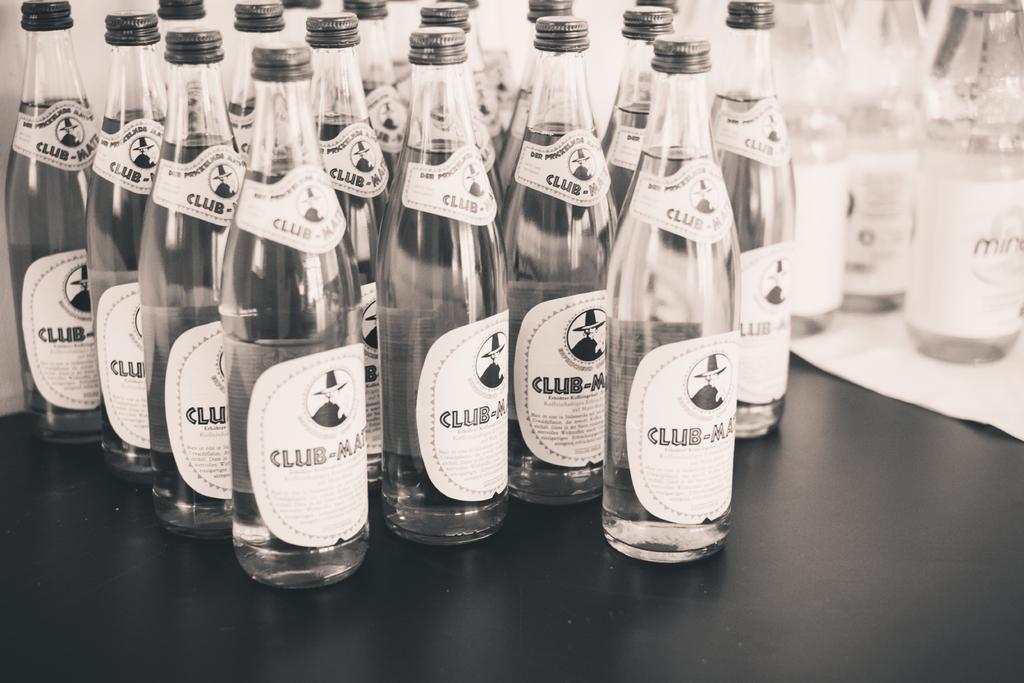What objects can be seen in the image? There are bottles in the image. Are there any distinguishing features on any of the bottles? Yes, there is a sticker on one of the bottles. Can you see a snake slithering around the bottles in the image? No, there is no snake present in the image. 